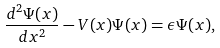Convert formula to latex. <formula><loc_0><loc_0><loc_500><loc_500>\frac { d ^ { 2 } \Psi ( x ) } { d x ^ { 2 } } - V ( x ) \Psi ( x ) = \epsilon \Psi ( x ) ,</formula> 